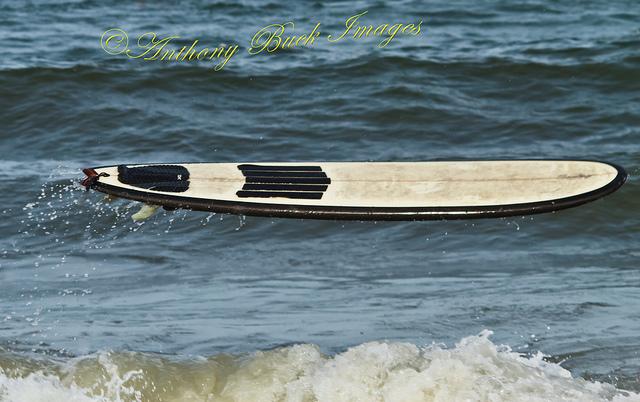Is the board on the sand?
Short answer required. No. Are there waves in the ocean?
Write a very short answer. Yes. What color is the board?
Short answer required. White. 